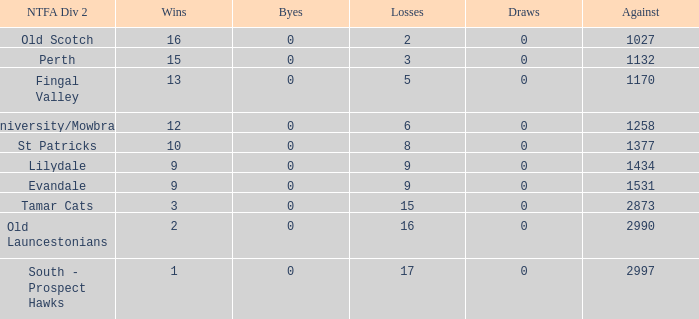What is the smallest number of draws of the ntfa div 2 lilydale? 0.0. 